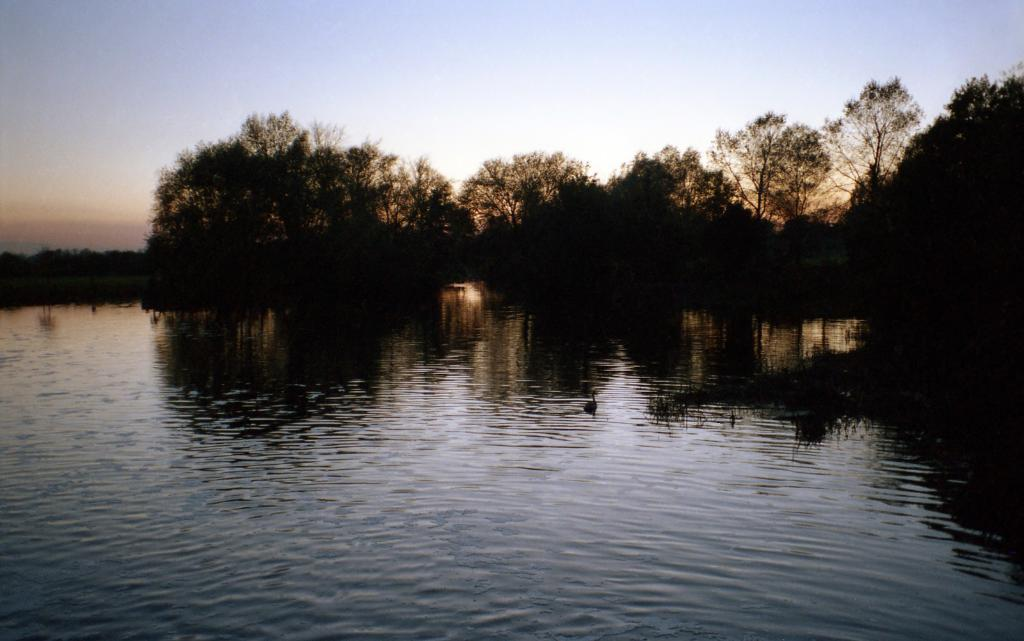What is at the bottom of the image? There is water at the bottom of the image. What can be seen in the water? There are birds in the water. What type of vegetation is present in the water? There is grass in the water. What is visible in the background of the image? There are trees in the background of the image. What is visible at the top of the image? The sky is visible at the top of the image. How does the disgust affect the cream in the image? There is no mention of disgust or cream in the image; it features water, birds, grass, trees, and the sky. 